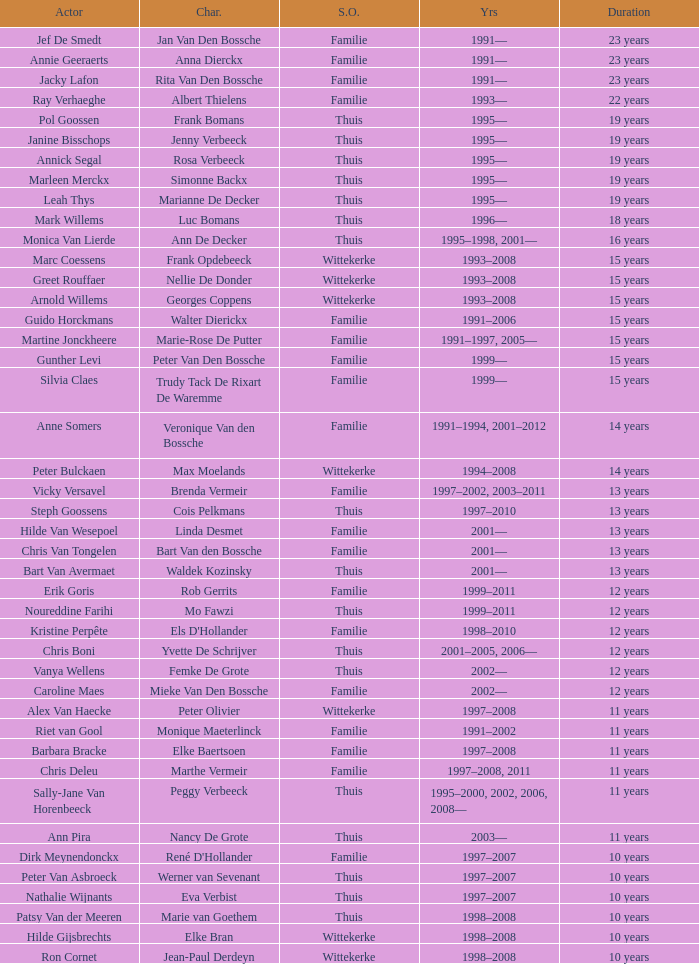What was the character vicky versavel played for a period of 13 years? Brenda Vermeir. 